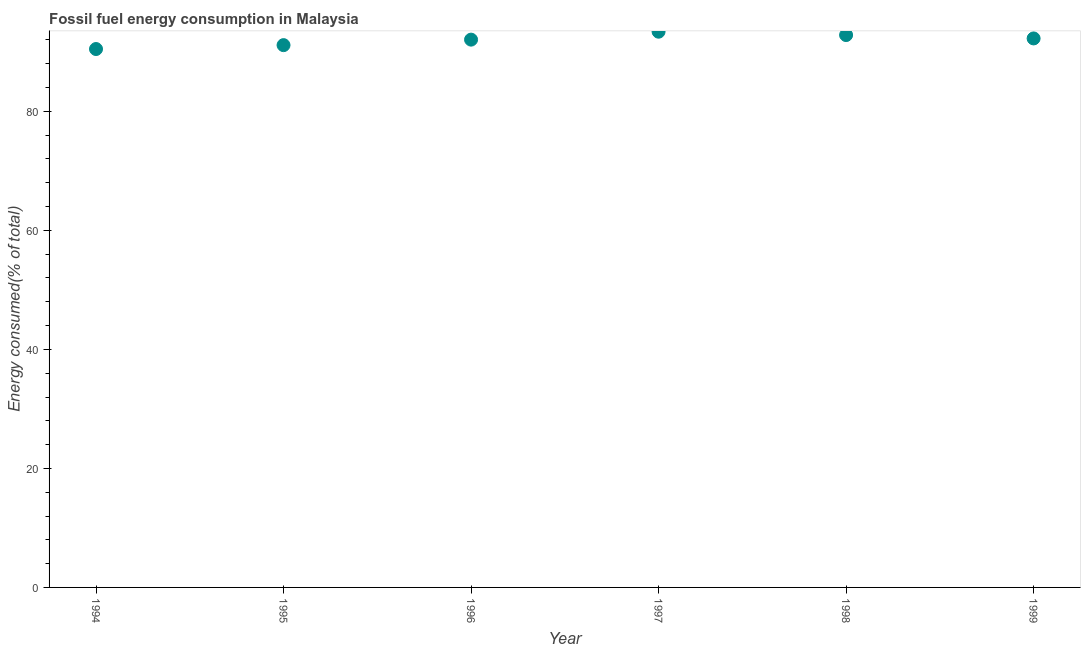What is the fossil fuel energy consumption in 1999?
Ensure brevity in your answer.  92.26. Across all years, what is the maximum fossil fuel energy consumption?
Keep it short and to the point. 93.39. Across all years, what is the minimum fossil fuel energy consumption?
Your response must be concise. 90.48. In which year was the fossil fuel energy consumption minimum?
Offer a very short reply. 1994. What is the sum of the fossil fuel energy consumption?
Give a very brief answer. 552.14. What is the difference between the fossil fuel energy consumption in 1994 and 1997?
Make the answer very short. -2.91. What is the average fossil fuel energy consumption per year?
Give a very brief answer. 92.02. What is the median fossil fuel energy consumption?
Provide a short and direct response. 92.16. Do a majority of the years between 1995 and 1997 (inclusive) have fossil fuel energy consumption greater than 36 %?
Offer a terse response. Yes. What is the ratio of the fossil fuel energy consumption in 1994 to that in 1998?
Ensure brevity in your answer.  0.97. Is the fossil fuel energy consumption in 1995 less than that in 1998?
Provide a succinct answer. Yes. What is the difference between the highest and the second highest fossil fuel energy consumption?
Ensure brevity in your answer.  0.57. What is the difference between the highest and the lowest fossil fuel energy consumption?
Your answer should be very brief. 2.91. In how many years, is the fossil fuel energy consumption greater than the average fossil fuel energy consumption taken over all years?
Your response must be concise. 4. Does the fossil fuel energy consumption monotonically increase over the years?
Make the answer very short. No. How many years are there in the graph?
Provide a succinct answer. 6. Does the graph contain any zero values?
Offer a very short reply. No. Does the graph contain grids?
Your answer should be compact. No. What is the title of the graph?
Give a very brief answer. Fossil fuel energy consumption in Malaysia. What is the label or title of the X-axis?
Provide a short and direct response. Year. What is the label or title of the Y-axis?
Offer a very short reply. Energy consumed(% of total). What is the Energy consumed(% of total) in 1994?
Your response must be concise. 90.48. What is the Energy consumed(% of total) in 1995?
Give a very brief answer. 91.13. What is the Energy consumed(% of total) in 1996?
Offer a very short reply. 92.06. What is the Energy consumed(% of total) in 1997?
Your response must be concise. 93.39. What is the Energy consumed(% of total) in 1998?
Give a very brief answer. 92.82. What is the Energy consumed(% of total) in 1999?
Offer a very short reply. 92.26. What is the difference between the Energy consumed(% of total) in 1994 and 1995?
Your answer should be very brief. -0.65. What is the difference between the Energy consumed(% of total) in 1994 and 1996?
Give a very brief answer. -1.58. What is the difference between the Energy consumed(% of total) in 1994 and 1997?
Offer a very short reply. -2.91. What is the difference between the Energy consumed(% of total) in 1994 and 1998?
Your answer should be compact. -2.35. What is the difference between the Energy consumed(% of total) in 1994 and 1999?
Provide a short and direct response. -1.78. What is the difference between the Energy consumed(% of total) in 1995 and 1996?
Your response must be concise. -0.93. What is the difference between the Energy consumed(% of total) in 1995 and 1997?
Your answer should be compact. -2.26. What is the difference between the Energy consumed(% of total) in 1995 and 1998?
Ensure brevity in your answer.  -1.69. What is the difference between the Energy consumed(% of total) in 1995 and 1999?
Offer a terse response. -1.13. What is the difference between the Energy consumed(% of total) in 1996 and 1997?
Provide a short and direct response. -1.33. What is the difference between the Energy consumed(% of total) in 1996 and 1998?
Offer a terse response. -0.77. What is the difference between the Energy consumed(% of total) in 1996 and 1999?
Provide a succinct answer. -0.2. What is the difference between the Energy consumed(% of total) in 1997 and 1998?
Offer a terse response. 0.57. What is the difference between the Energy consumed(% of total) in 1997 and 1999?
Provide a succinct answer. 1.13. What is the difference between the Energy consumed(% of total) in 1998 and 1999?
Ensure brevity in your answer.  0.57. What is the ratio of the Energy consumed(% of total) in 1994 to that in 1997?
Offer a terse response. 0.97. What is the ratio of the Energy consumed(% of total) in 1994 to that in 1999?
Your answer should be compact. 0.98. What is the ratio of the Energy consumed(% of total) in 1995 to that in 1998?
Keep it short and to the point. 0.98. What is the ratio of the Energy consumed(% of total) in 1995 to that in 1999?
Offer a terse response. 0.99. What is the ratio of the Energy consumed(% of total) in 1996 to that in 1997?
Offer a terse response. 0.99. What is the ratio of the Energy consumed(% of total) in 1996 to that in 1998?
Your answer should be compact. 0.99. What is the ratio of the Energy consumed(% of total) in 1996 to that in 1999?
Provide a succinct answer. 1. 